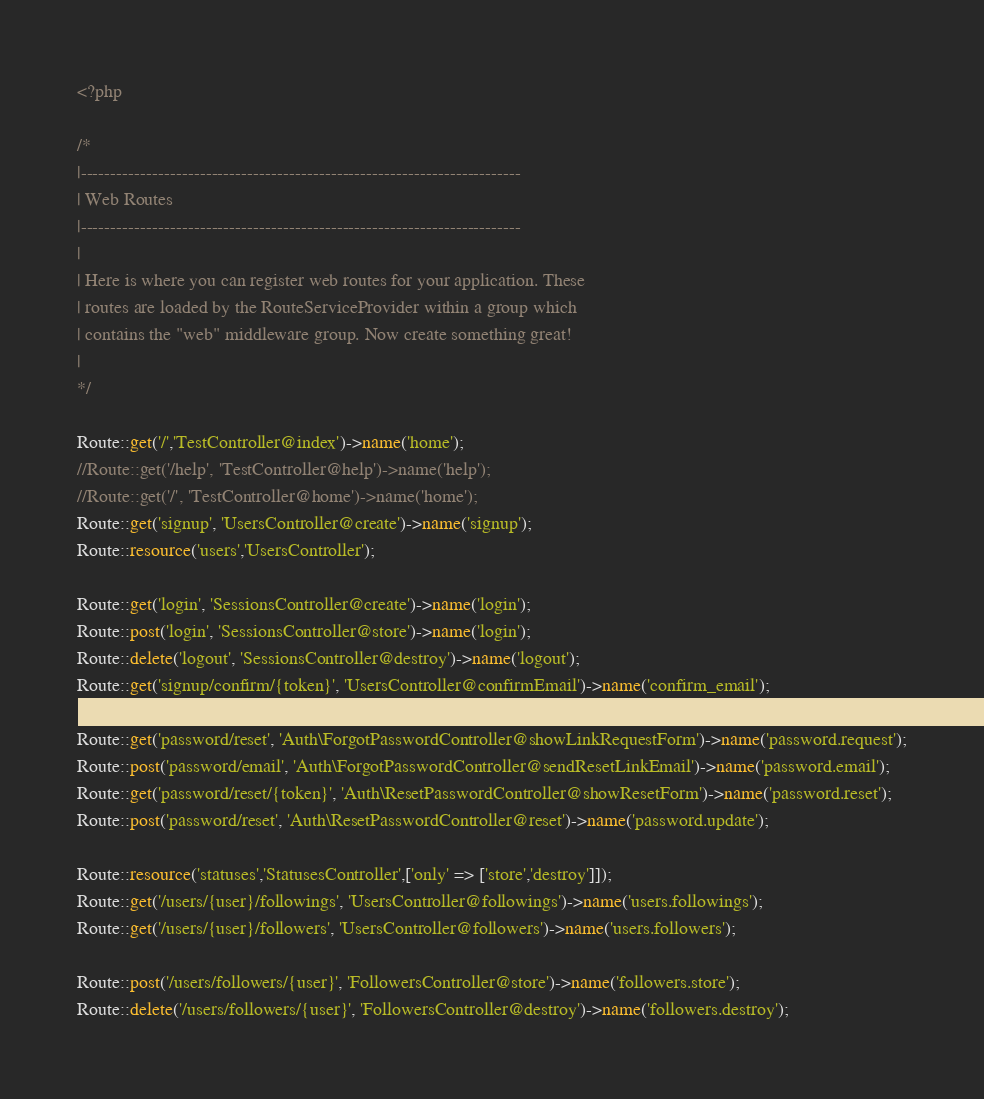<code> <loc_0><loc_0><loc_500><loc_500><_PHP_><?php

/*
|--------------------------------------------------------------------------
| Web Routes
|--------------------------------------------------------------------------
|
| Here is where you can register web routes for your application. These
| routes are loaded by the RouteServiceProvider within a group which
| contains the "web" middleware group. Now create something great!
|
*/

Route::get('/','TestController@index')->name('home');
//Route::get('/help', 'TestController@help')->name('help');
//Route::get('/', 'TestController@home')->name('home');
Route::get('signup', 'UsersController@create')->name('signup');
Route::resource('users','UsersController');

Route::get('login', 'SessionsController@create')->name('login');
Route::post('login', 'SessionsController@store')->name('login');
Route::delete('logout', 'SessionsController@destroy')->name('logout');
Route::get('signup/confirm/{token}', 'UsersController@confirmEmail')->name('confirm_email');

Route::get('password/reset', 'Auth\ForgotPasswordController@showLinkRequestForm')->name('password.request');
Route::post('password/email', 'Auth\ForgotPasswordController@sendResetLinkEmail')->name('password.email');
Route::get('password/reset/{token}', 'Auth\ResetPasswordController@showResetForm')->name('password.reset');
Route::post('password/reset', 'Auth\ResetPasswordController@reset')->name('password.update');

Route::resource('statuses','StatusesController',['only' => ['store','destroy']]);
Route::get('/users/{user}/followings', 'UsersController@followings')->name('users.followings');
Route::get('/users/{user}/followers', 'UsersController@followers')->name('users.followers');

Route::post('/users/followers/{user}', 'FollowersController@store')->name('followers.store');
Route::delete('/users/followers/{user}', 'FollowersController@destroy')->name('followers.destroy');
</code> 